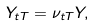<formula> <loc_0><loc_0><loc_500><loc_500>Y _ { t T } = \nu _ { t T } Y ,</formula> 